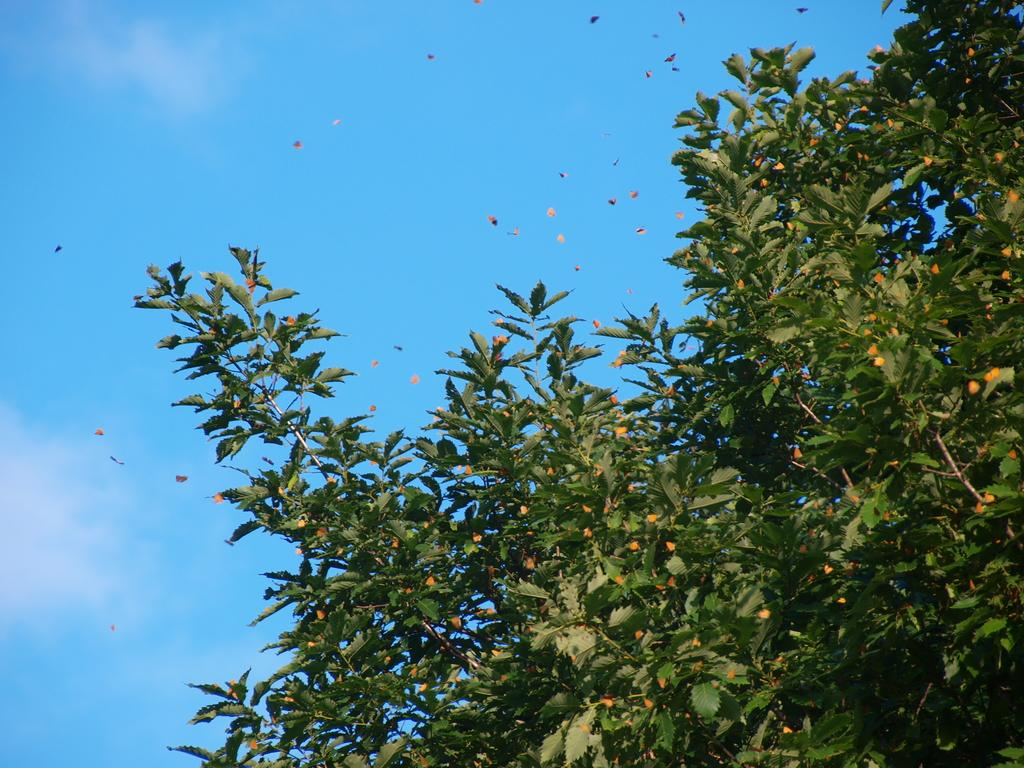What type of plant can be seen in the image? There is a tree in the image. What other living organisms are present in the image? There are butterflies in the image. What part of the natural environment is visible in the image? The sky is visible in the image. What type of marble is the aunt holding in the image? There is no aunt or marble present in the image. What year is depicted in the image? The image does not depict a specific year; it features a tree, butterflies, and the sky. 